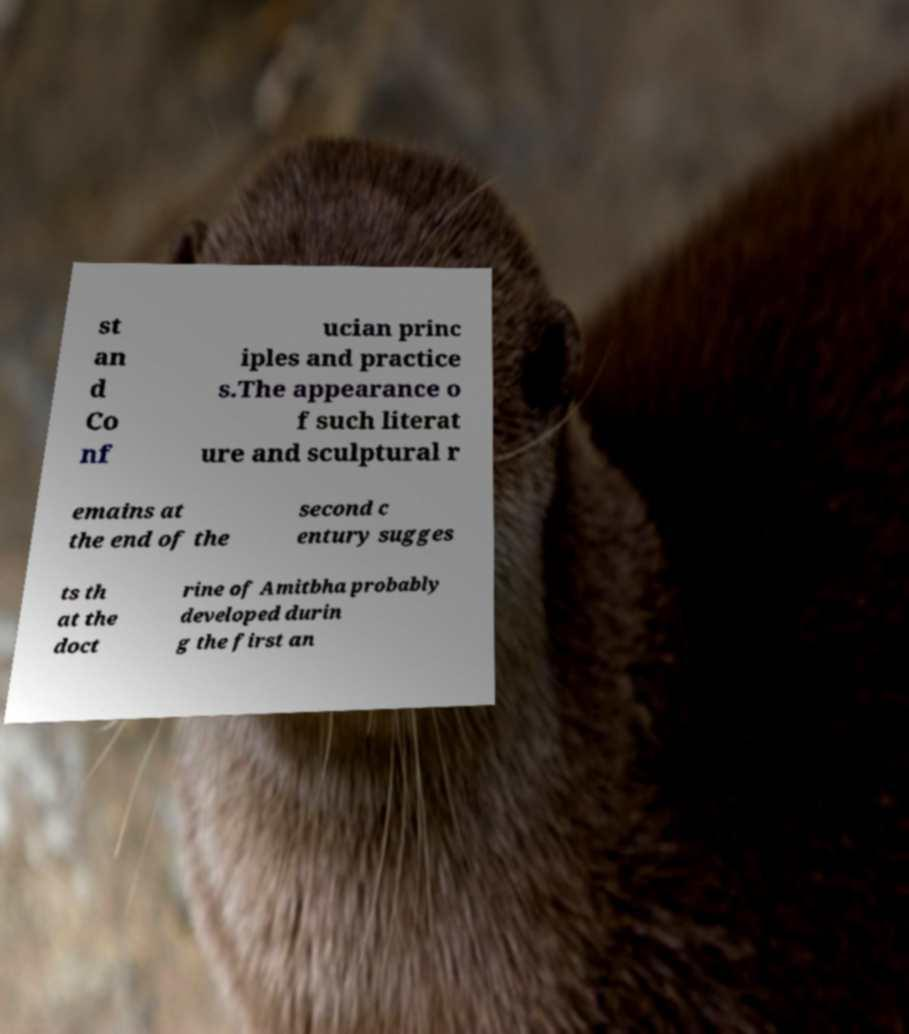For documentation purposes, I need the text within this image transcribed. Could you provide that? st an d Co nf ucian princ iples and practice s.The appearance o f such literat ure and sculptural r emains at the end of the second c entury sugges ts th at the doct rine of Amitbha probably developed durin g the first an 